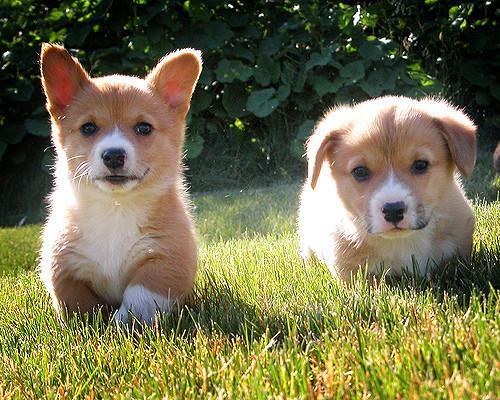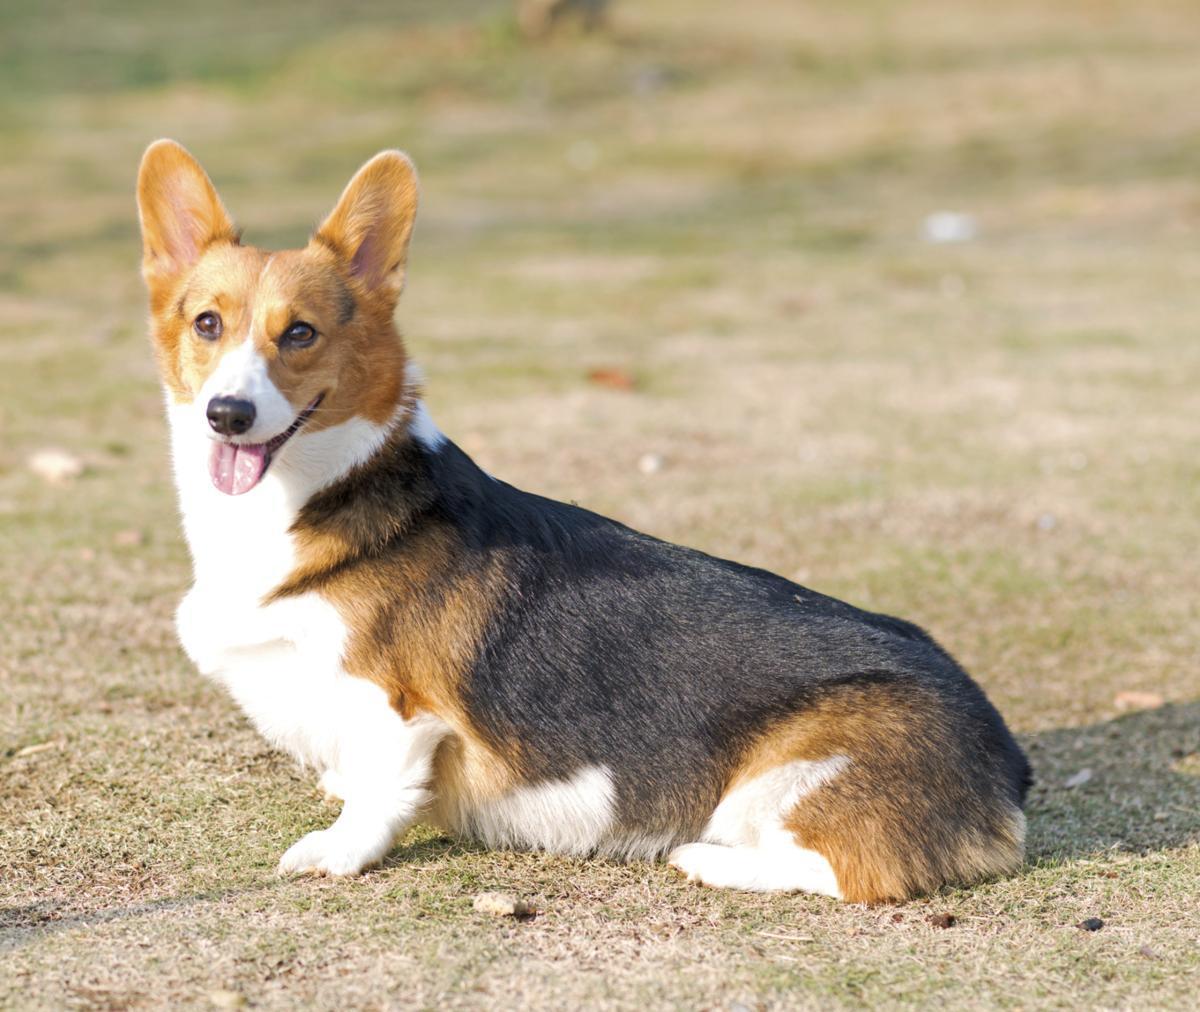The first image is the image on the left, the second image is the image on the right. For the images displayed, is the sentence "One of the images shows two corgis in close proximity to each other." factually correct? Answer yes or no. Yes. The first image is the image on the left, the second image is the image on the right. Considering the images on both sides, is "There are at most two corgis." valid? Answer yes or no. No. 